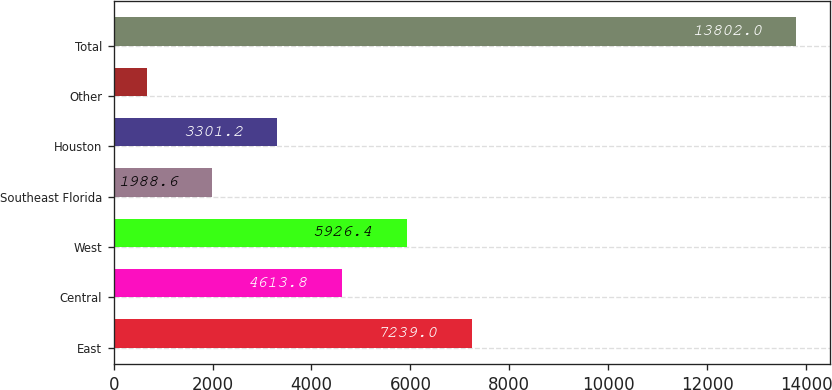<chart> <loc_0><loc_0><loc_500><loc_500><bar_chart><fcel>East<fcel>Central<fcel>West<fcel>Southeast Florida<fcel>Houston<fcel>Other<fcel>Total<nl><fcel>7239<fcel>4613.8<fcel>5926.4<fcel>1988.6<fcel>3301.2<fcel>676<fcel>13802<nl></chart> 